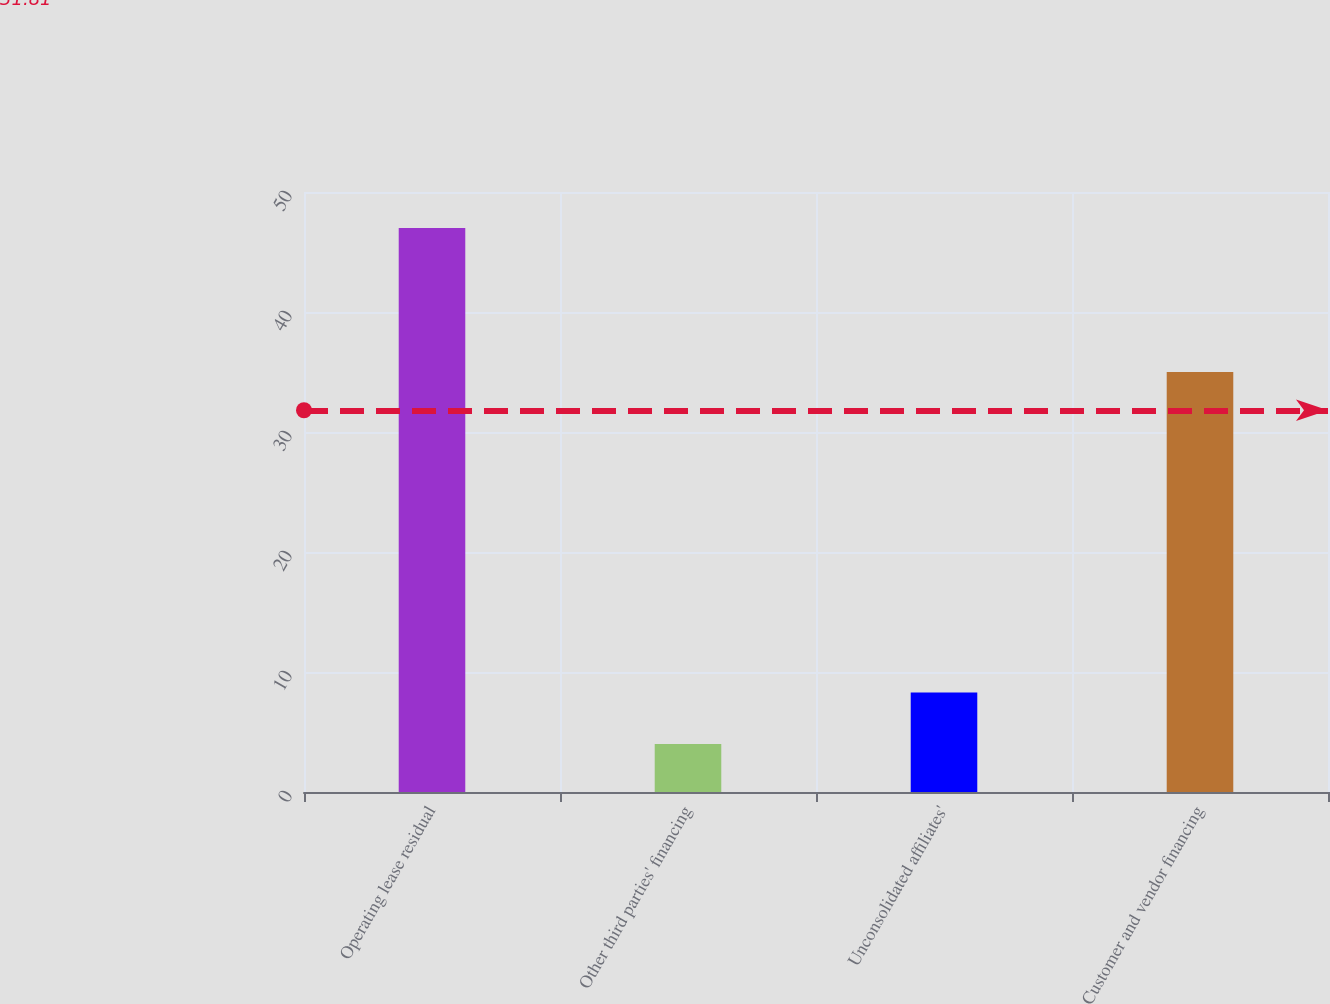Convert chart. <chart><loc_0><loc_0><loc_500><loc_500><bar_chart><fcel>Operating lease residual<fcel>Other third parties' financing<fcel>Unconsolidated affiliates'<fcel>Customer and vendor financing<nl><fcel>47<fcel>4<fcel>8.3<fcel>35<nl></chart> 